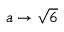Convert formula to latex. <formula><loc_0><loc_0><loc_500><loc_500>a \rightarrow { \sqrt { 6 } }</formula> 